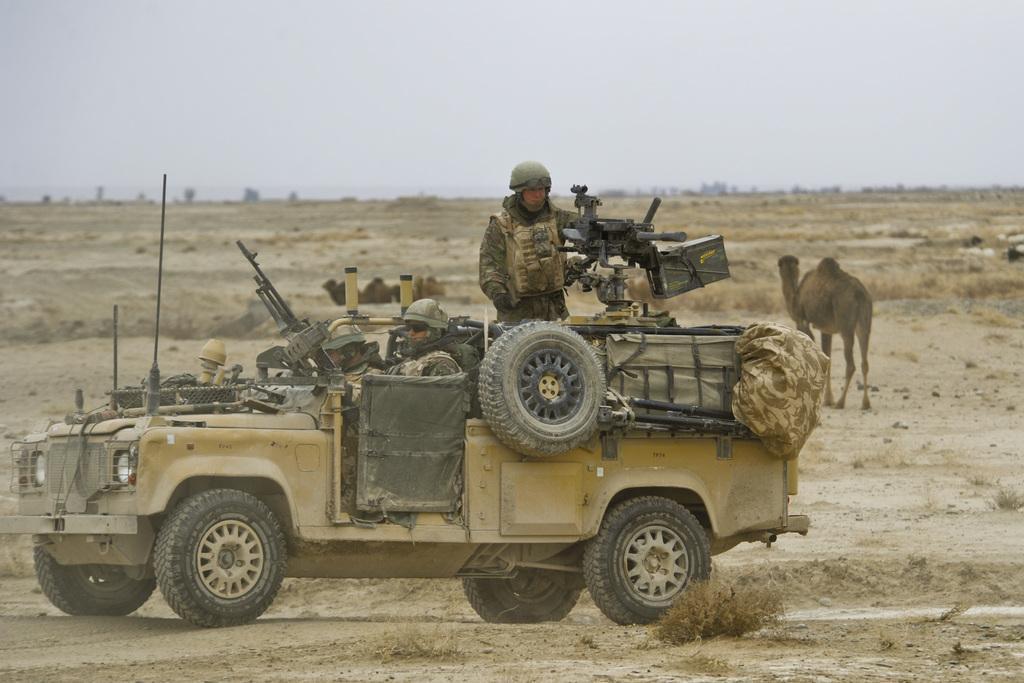Can you describe this image briefly? In this picture there is a jeep in the center of the image and there are soldiers in it, by holding guns in there hands and there are camels in the background area of the image. 